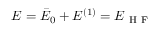<formula> <loc_0><loc_0><loc_500><loc_500>E = \bar { E } _ { 0 } + E ^ { ( 1 ) } = E _ { H F }</formula> 